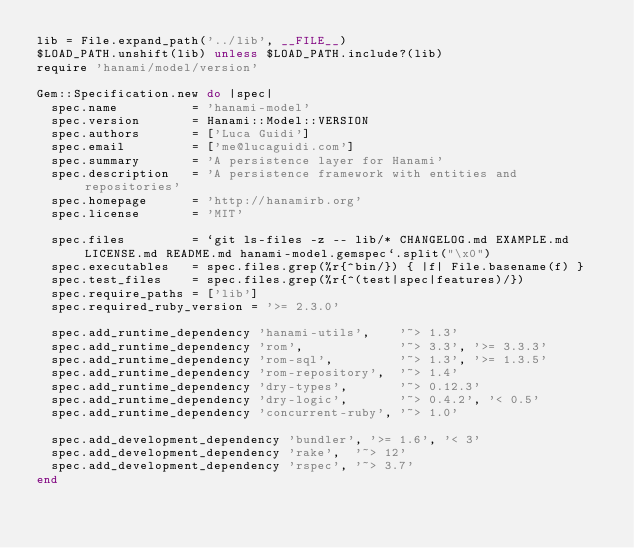Convert code to text. <code><loc_0><loc_0><loc_500><loc_500><_Ruby_>lib = File.expand_path('../lib', __FILE__)
$LOAD_PATH.unshift(lib) unless $LOAD_PATH.include?(lib)
require 'hanami/model/version'

Gem::Specification.new do |spec|
  spec.name          = 'hanami-model'
  spec.version       = Hanami::Model::VERSION
  spec.authors       = ['Luca Guidi']
  spec.email         = ['me@lucaguidi.com']
  spec.summary       = 'A persistence layer for Hanami'
  spec.description   = 'A persistence framework with entities and repositories'
  spec.homepage      = 'http://hanamirb.org'
  spec.license       = 'MIT'

  spec.files         = `git ls-files -z -- lib/* CHANGELOG.md EXAMPLE.md LICENSE.md README.md hanami-model.gemspec`.split("\x0")
  spec.executables   = spec.files.grep(%r{^bin/}) { |f| File.basename(f) }
  spec.test_files    = spec.files.grep(%r{^(test|spec|features)/})
  spec.require_paths = ['lib']
  spec.required_ruby_version = '>= 2.3.0'

  spec.add_runtime_dependency 'hanami-utils',    '~> 1.3'
  spec.add_runtime_dependency 'rom',             '~> 3.3', '>= 3.3.3'
  spec.add_runtime_dependency 'rom-sql',         '~> 1.3', '>= 1.3.5'
  spec.add_runtime_dependency 'rom-repository',  '~> 1.4'
  spec.add_runtime_dependency 'dry-types',       '~> 0.12.3'
  spec.add_runtime_dependency 'dry-logic',       '~> 0.4.2', '< 0.5'
  spec.add_runtime_dependency 'concurrent-ruby', '~> 1.0'

  spec.add_development_dependency 'bundler', '>= 1.6', '< 3'
  spec.add_development_dependency 'rake',  '~> 12'
  spec.add_development_dependency 'rspec', '~> 3.7'
end
</code> 